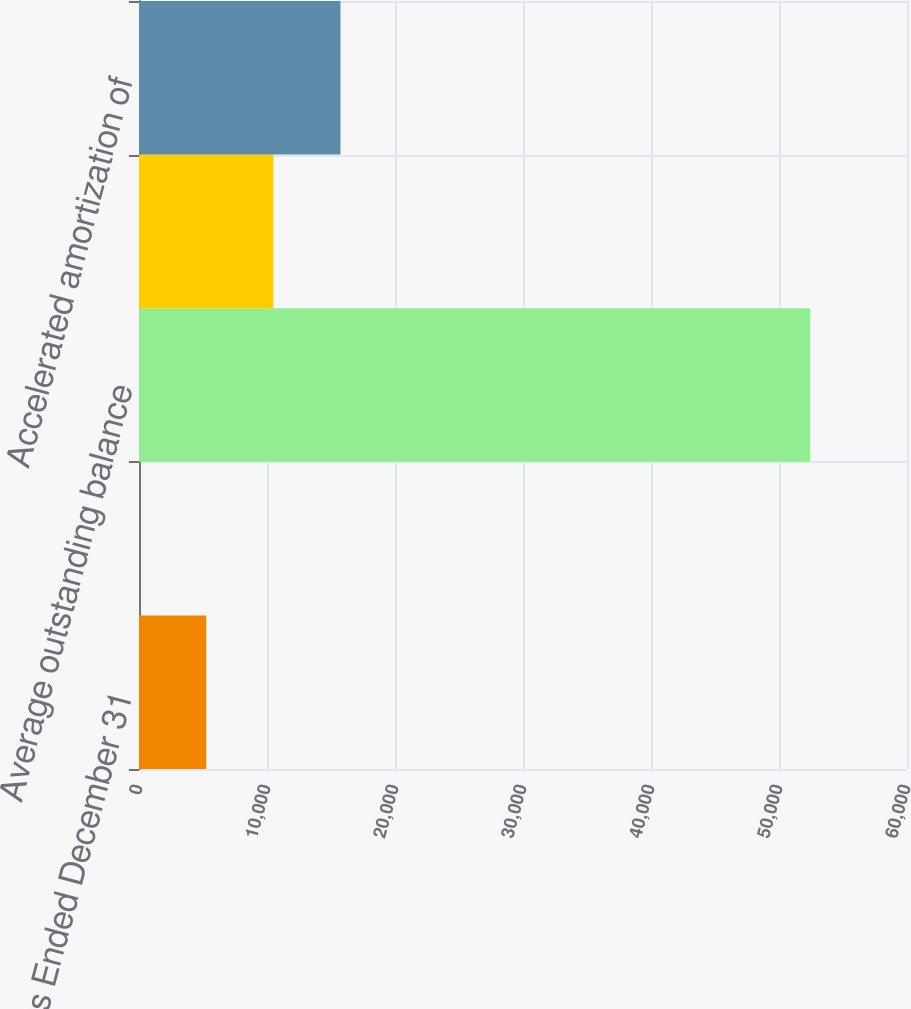<chart> <loc_0><loc_0><loc_500><loc_500><bar_chart><fcel>Years Ended December 31<fcel>Weighted average interest rate<fcel>Average outstanding balance<fcel>Periodic amortization of<fcel>Accelerated amortization of<nl><fcel>5253.44<fcel>10.6<fcel>52439<fcel>10496.3<fcel>15739.1<nl></chart> 